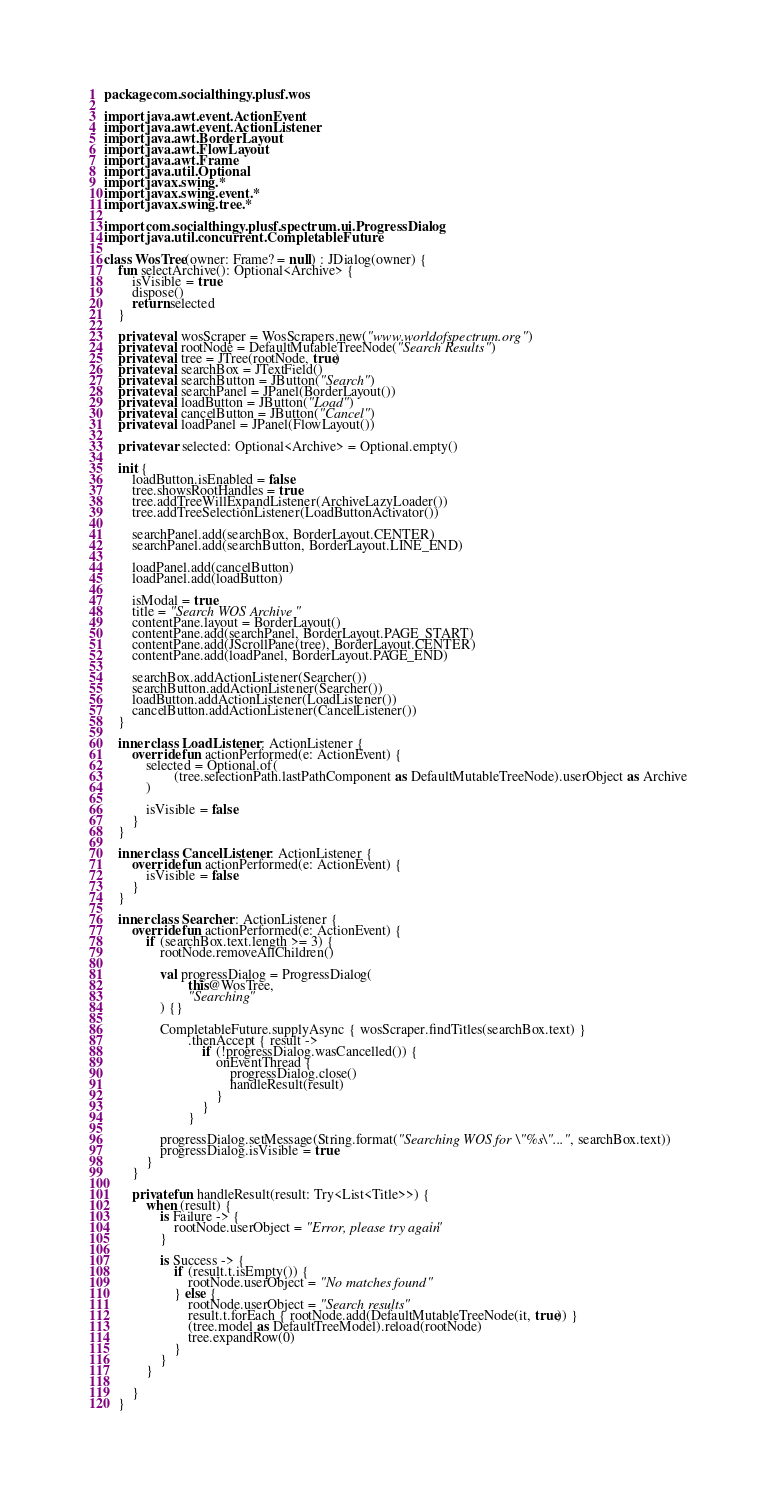Convert code to text. <code><loc_0><loc_0><loc_500><loc_500><_Kotlin_>package com.socialthingy.plusf.wos

import java.awt.event.ActionEvent
import java.awt.event.ActionListener
import java.awt.BorderLayout
import java.awt.FlowLayout
import java.awt.Frame
import java.util.Optional
import javax.swing.*
import javax.swing.event.*
import javax.swing.tree.*

import com.socialthingy.plusf.spectrum.ui.ProgressDialog
import java.util.concurrent.CompletableFuture

class WosTree(owner: Frame? = null) : JDialog(owner) {
    fun selectArchive(): Optional<Archive> {
        isVisible = true
        dispose()
        return selected
    }

    private val wosScraper = WosScrapers.new("www.worldofspectrum.org")
    private val rootNode = DefaultMutableTreeNode("Search Results")
    private val tree = JTree(rootNode, true)
    private val searchBox = JTextField()
    private val searchButton = JButton("Search")
    private val searchPanel = JPanel(BorderLayout())
    private val loadButton = JButton("Load")
    private val cancelButton = JButton("Cancel")
    private val loadPanel = JPanel(FlowLayout())

    private var selected: Optional<Archive> = Optional.empty()

    init {
        loadButton.isEnabled = false
        tree.showsRootHandles = true
        tree.addTreeWillExpandListener(ArchiveLazyLoader())
        tree.addTreeSelectionListener(LoadButtonActivator())

        searchPanel.add(searchBox, BorderLayout.CENTER)
        searchPanel.add(searchButton, BorderLayout.LINE_END)

        loadPanel.add(cancelButton)
        loadPanel.add(loadButton)

        isModal = true
        title = "Search WOS Archive"
        contentPane.layout = BorderLayout()
        contentPane.add(searchPanel, BorderLayout.PAGE_START)
        contentPane.add(JScrollPane(tree), BorderLayout.CENTER)
        contentPane.add(loadPanel, BorderLayout.PAGE_END)

        searchBox.addActionListener(Searcher())
        searchButton.addActionListener(Searcher())
        loadButton.addActionListener(LoadListener())
        cancelButton.addActionListener(CancelListener())
    }

    inner class LoadListener : ActionListener {
        override fun actionPerformed(e: ActionEvent) {
            selected = Optional.of(
                    (tree.selectionPath.lastPathComponent as DefaultMutableTreeNode).userObject as Archive
            )

            isVisible = false
        }
    }

    inner class CancelListener : ActionListener {
        override fun actionPerformed(e: ActionEvent) {
            isVisible = false
        }
    }

    inner class Searcher : ActionListener {
        override fun actionPerformed(e: ActionEvent) {
            if (searchBox.text.length >= 3) {
                rootNode.removeAllChildren()

                val progressDialog = ProgressDialog(
                        this@WosTree,
                        "Searching"
                ) {}

                CompletableFuture.supplyAsync { wosScraper.findTitles(searchBox.text) }
                        .thenAccept { result ->
                            if (!progressDialog.wasCancelled()) {
                                onEventThread {
                                    progressDialog.close()
                                    handleResult(result)
                                }
                            }
                        }

                progressDialog.setMessage(String.format("Searching WOS for \"%s\"...", searchBox.text))
                progressDialog.isVisible = true
            }
        }

        private fun handleResult(result: Try<List<Title>>) {
            when (result) {
                is Failure -> {
                    rootNode.userObject = "Error, please try again"
                }

                is Success -> {
                    if (result.t.isEmpty()) {
                        rootNode.userObject = "No matches found"
                    } else {
                        rootNode.userObject = "Search results"
                        result.t.forEach { rootNode.add(DefaultMutableTreeNode(it, true)) }
                        (tree.model as DefaultTreeModel).reload(rootNode)
                        tree.expandRow(0)
                    }
                }
            }

        }
    }
</code> 